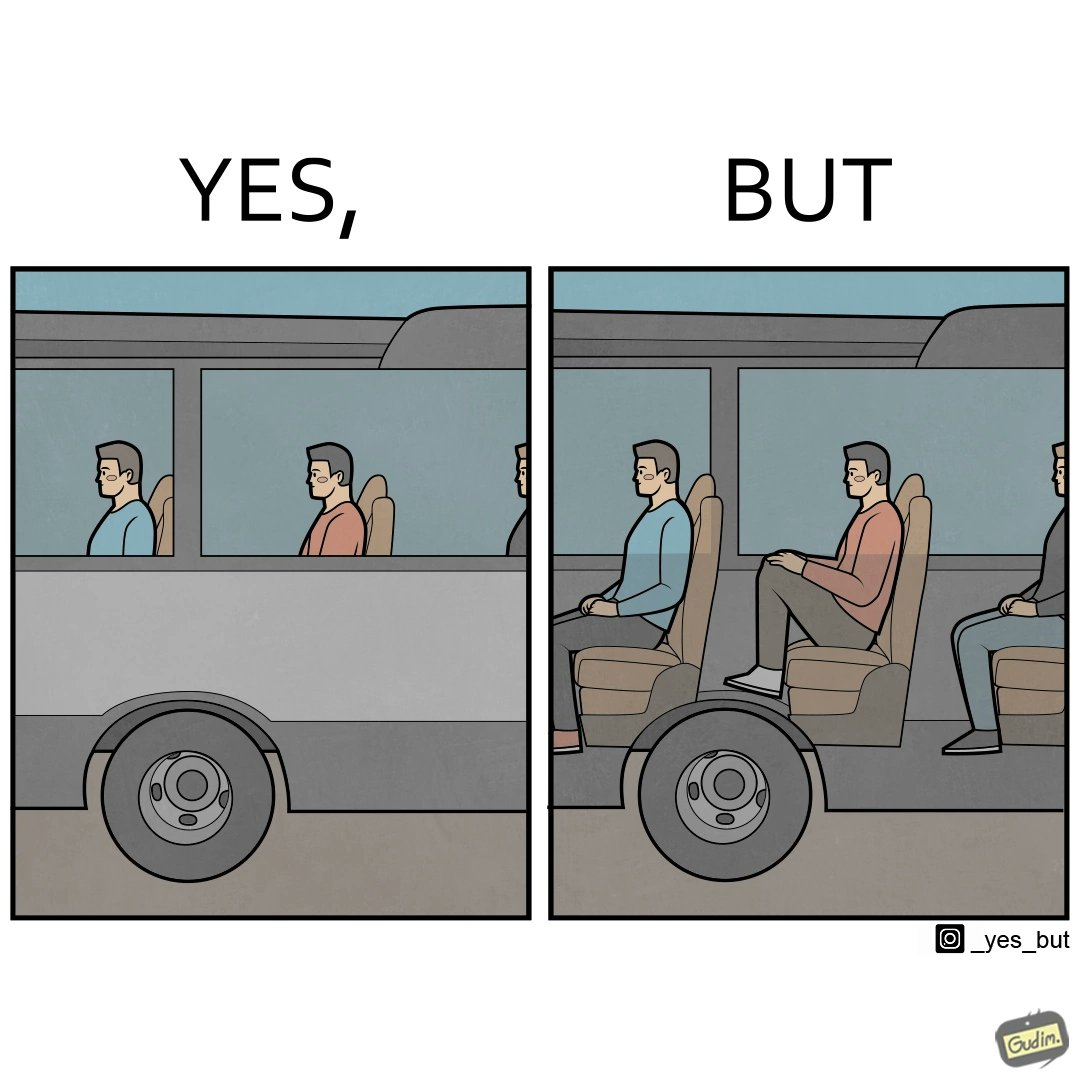Describe what you see in this image. the irony in this image is that the seat right above a bus' wheels is the most uncomfortable one. 